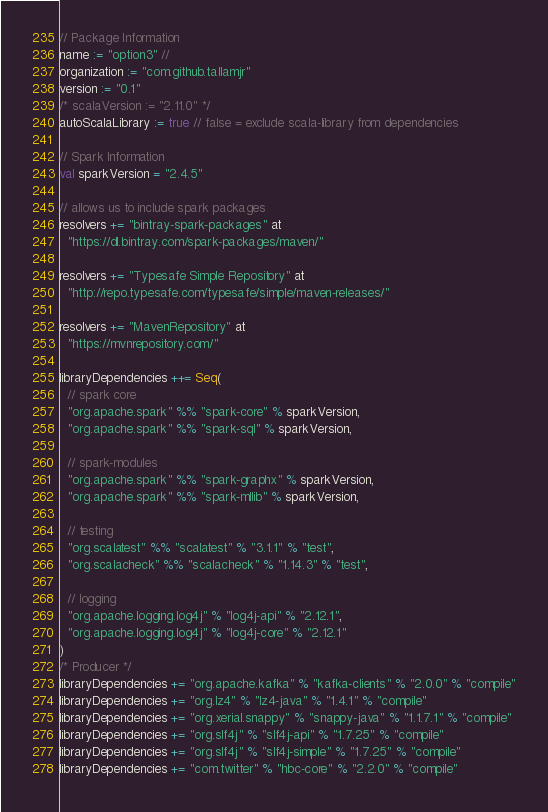<code> <loc_0><loc_0><loc_500><loc_500><_Scala_>// Package Information
name := "option3" //
organization := "com.github.tallamjr"
version := "0.1"
/* scalaVersion := "2.11.0" */
autoScalaLibrary := true // false = exclude scala-library from dependencies

// Spark Information
val sparkVersion = "2.4.5"

// allows us to include spark packages
resolvers += "bintray-spark-packages" at
  "https://dl.bintray.com/spark-packages/maven/"

resolvers += "Typesafe Simple Repository" at
  "http://repo.typesafe.com/typesafe/simple/maven-releases/"

resolvers += "MavenRepository" at
  "https://mvnrepository.com/"

libraryDependencies ++= Seq(
  // spark core
  "org.apache.spark" %% "spark-core" % sparkVersion,
  "org.apache.spark" %% "spark-sql" % sparkVersion,

  // spark-modules
  "org.apache.spark" %% "spark-graphx" % sparkVersion,
  "org.apache.spark" %% "spark-mllib" % sparkVersion,

  // testing
  "org.scalatest" %% "scalatest" % "3.1.1" % "test",
  "org.scalacheck" %% "scalacheck" % "1.14.3" % "test",

  // logging
  "org.apache.logging.log4j" % "log4j-api" % "2.12.1",
  "org.apache.logging.log4j" % "log4j-core" % "2.12.1"
)
/* Producer */
libraryDependencies += "org.apache.kafka" % "kafka-clients" % "2.0.0" % "compile"
libraryDependencies += "org.lz4" % "lz4-java" % "1.4.1" % "compile"
libraryDependencies += "org.xerial.snappy" % "snappy-java" % "1.1.7.1" % "compile"
libraryDependencies += "org.slf4j" % "slf4j-api" % "1.7.25" % "compile"
libraryDependencies += "org.slf4j" % "slf4j-simple" % "1.7.25" % "compile"
libraryDependencies += "com.twitter" % "hbc-core" % "2.2.0" % "compile"</code> 